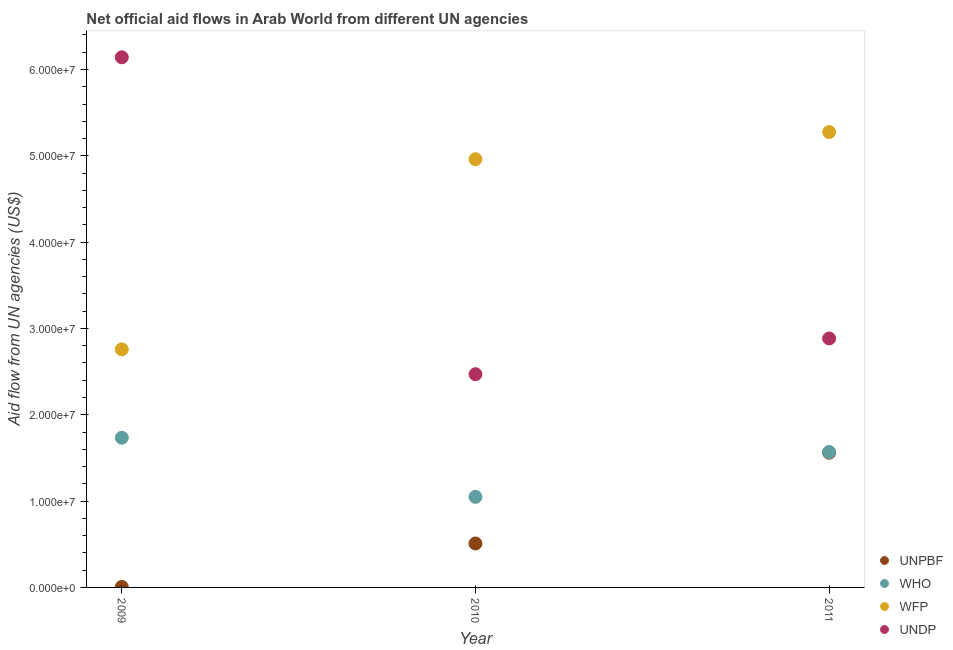How many different coloured dotlines are there?
Your answer should be very brief. 4. What is the amount of aid given by wfp in 2009?
Ensure brevity in your answer.  2.76e+07. Across all years, what is the maximum amount of aid given by who?
Keep it short and to the point. 1.73e+07. Across all years, what is the minimum amount of aid given by who?
Provide a succinct answer. 1.05e+07. In which year was the amount of aid given by who minimum?
Your answer should be compact. 2010. What is the total amount of aid given by undp in the graph?
Your answer should be very brief. 1.15e+08. What is the difference between the amount of aid given by undp in 2009 and that in 2010?
Make the answer very short. 3.67e+07. What is the difference between the amount of aid given by unpbf in 2010 and the amount of aid given by undp in 2009?
Make the answer very short. -5.63e+07. What is the average amount of aid given by unpbf per year?
Provide a short and direct response. 6.92e+06. In the year 2010, what is the difference between the amount of aid given by undp and amount of aid given by who?
Your answer should be compact. 1.42e+07. In how many years, is the amount of aid given by unpbf greater than 8000000 US$?
Keep it short and to the point. 1. What is the ratio of the amount of aid given by wfp in 2009 to that in 2010?
Provide a short and direct response. 0.56. What is the difference between the highest and the second highest amount of aid given by wfp?
Keep it short and to the point. 3.14e+06. What is the difference between the highest and the lowest amount of aid given by undp?
Your response must be concise. 3.67e+07. Is it the case that in every year, the sum of the amount of aid given by unpbf and amount of aid given by who is greater than the amount of aid given by wfp?
Give a very brief answer. No. Is the amount of aid given by undp strictly less than the amount of aid given by wfp over the years?
Your answer should be very brief. No. What is the difference between two consecutive major ticks on the Y-axis?
Give a very brief answer. 1.00e+07. Are the values on the major ticks of Y-axis written in scientific E-notation?
Keep it short and to the point. Yes. What is the title of the graph?
Offer a very short reply. Net official aid flows in Arab World from different UN agencies. Does "Greece" appear as one of the legend labels in the graph?
Ensure brevity in your answer.  No. What is the label or title of the Y-axis?
Give a very brief answer. Aid flow from UN agencies (US$). What is the Aid flow from UN agencies (US$) in UNPBF in 2009?
Give a very brief answer. 6.00e+04. What is the Aid flow from UN agencies (US$) of WHO in 2009?
Your answer should be compact. 1.73e+07. What is the Aid flow from UN agencies (US$) of WFP in 2009?
Ensure brevity in your answer.  2.76e+07. What is the Aid flow from UN agencies (US$) of UNDP in 2009?
Make the answer very short. 6.14e+07. What is the Aid flow from UN agencies (US$) of UNPBF in 2010?
Your response must be concise. 5.09e+06. What is the Aid flow from UN agencies (US$) in WHO in 2010?
Make the answer very short. 1.05e+07. What is the Aid flow from UN agencies (US$) in WFP in 2010?
Ensure brevity in your answer.  4.96e+07. What is the Aid flow from UN agencies (US$) of UNDP in 2010?
Provide a succinct answer. 2.47e+07. What is the Aid flow from UN agencies (US$) in UNPBF in 2011?
Your response must be concise. 1.56e+07. What is the Aid flow from UN agencies (US$) in WHO in 2011?
Offer a very short reply. 1.57e+07. What is the Aid flow from UN agencies (US$) of WFP in 2011?
Keep it short and to the point. 5.28e+07. What is the Aid flow from UN agencies (US$) of UNDP in 2011?
Your answer should be compact. 2.88e+07. Across all years, what is the maximum Aid flow from UN agencies (US$) in UNPBF?
Provide a succinct answer. 1.56e+07. Across all years, what is the maximum Aid flow from UN agencies (US$) in WHO?
Your answer should be very brief. 1.73e+07. Across all years, what is the maximum Aid flow from UN agencies (US$) in WFP?
Ensure brevity in your answer.  5.28e+07. Across all years, what is the maximum Aid flow from UN agencies (US$) in UNDP?
Keep it short and to the point. 6.14e+07. Across all years, what is the minimum Aid flow from UN agencies (US$) of UNPBF?
Keep it short and to the point. 6.00e+04. Across all years, what is the minimum Aid flow from UN agencies (US$) of WHO?
Offer a very short reply. 1.05e+07. Across all years, what is the minimum Aid flow from UN agencies (US$) in WFP?
Provide a succinct answer. 2.76e+07. Across all years, what is the minimum Aid flow from UN agencies (US$) in UNDP?
Your answer should be compact. 2.47e+07. What is the total Aid flow from UN agencies (US$) of UNPBF in the graph?
Offer a very short reply. 2.08e+07. What is the total Aid flow from UN agencies (US$) in WHO in the graph?
Offer a terse response. 4.35e+07. What is the total Aid flow from UN agencies (US$) of WFP in the graph?
Offer a terse response. 1.30e+08. What is the total Aid flow from UN agencies (US$) of UNDP in the graph?
Give a very brief answer. 1.15e+08. What is the difference between the Aid flow from UN agencies (US$) of UNPBF in 2009 and that in 2010?
Provide a succinct answer. -5.03e+06. What is the difference between the Aid flow from UN agencies (US$) in WHO in 2009 and that in 2010?
Your response must be concise. 6.85e+06. What is the difference between the Aid flow from UN agencies (US$) in WFP in 2009 and that in 2010?
Give a very brief answer. -2.20e+07. What is the difference between the Aid flow from UN agencies (US$) in UNDP in 2009 and that in 2010?
Offer a terse response. 3.67e+07. What is the difference between the Aid flow from UN agencies (US$) of UNPBF in 2009 and that in 2011?
Keep it short and to the point. -1.56e+07. What is the difference between the Aid flow from UN agencies (US$) of WHO in 2009 and that in 2011?
Your answer should be very brief. 1.65e+06. What is the difference between the Aid flow from UN agencies (US$) in WFP in 2009 and that in 2011?
Your answer should be very brief. -2.52e+07. What is the difference between the Aid flow from UN agencies (US$) in UNDP in 2009 and that in 2011?
Your answer should be very brief. 3.26e+07. What is the difference between the Aid flow from UN agencies (US$) of UNPBF in 2010 and that in 2011?
Provide a short and direct response. -1.05e+07. What is the difference between the Aid flow from UN agencies (US$) in WHO in 2010 and that in 2011?
Provide a short and direct response. -5.20e+06. What is the difference between the Aid flow from UN agencies (US$) in WFP in 2010 and that in 2011?
Keep it short and to the point. -3.14e+06. What is the difference between the Aid flow from UN agencies (US$) of UNDP in 2010 and that in 2011?
Your answer should be very brief. -4.14e+06. What is the difference between the Aid flow from UN agencies (US$) in UNPBF in 2009 and the Aid flow from UN agencies (US$) in WHO in 2010?
Your answer should be very brief. -1.04e+07. What is the difference between the Aid flow from UN agencies (US$) in UNPBF in 2009 and the Aid flow from UN agencies (US$) in WFP in 2010?
Offer a very short reply. -4.96e+07. What is the difference between the Aid flow from UN agencies (US$) of UNPBF in 2009 and the Aid flow from UN agencies (US$) of UNDP in 2010?
Your response must be concise. -2.46e+07. What is the difference between the Aid flow from UN agencies (US$) in WHO in 2009 and the Aid flow from UN agencies (US$) in WFP in 2010?
Provide a short and direct response. -3.23e+07. What is the difference between the Aid flow from UN agencies (US$) of WHO in 2009 and the Aid flow from UN agencies (US$) of UNDP in 2010?
Ensure brevity in your answer.  -7.36e+06. What is the difference between the Aid flow from UN agencies (US$) of WFP in 2009 and the Aid flow from UN agencies (US$) of UNDP in 2010?
Provide a succinct answer. 2.88e+06. What is the difference between the Aid flow from UN agencies (US$) of UNPBF in 2009 and the Aid flow from UN agencies (US$) of WHO in 2011?
Make the answer very short. -1.56e+07. What is the difference between the Aid flow from UN agencies (US$) in UNPBF in 2009 and the Aid flow from UN agencies (US$) in WFP in 2011?
Provide a short and direct response. -5.27e+07. What is the difference between the Aid flow from UN agencies (US$) in UNPBF in 2009 and the Aid flow from UN agencies (US$) in UNDP in 2011?
Provide a succinct answer. -2.88e+07. What is the difference between the Aid flow from UN agencies (US$) of WHO in 2009 and the Aid flow from UN agencies (US$) of WFP in 2011?
Give a very brief answer. -3.54e+07. What is the difference between the Aid flow from UN agencies (US$) of WHO in 2009 and the Aid flow from UN agencies (US$) of UNDP in 2011?
Keep it short and to the point. -1.15e+07. What is the difference between the Aid flow from UN agencies (US$) in WFP in 2009 and the Aid flow from UN agencies (US$) in UNDP in 2011?
Ensure brevity in your answer.  -1.26e+06. What is the difference between the Aid flow from UN agencies (US$) of UNPBF in 2010 and the Aid flow from UN agencies (US$) of WHO in 2011?
Your response must be concise. -1.06e+07. What is the difference between the Aid flow from UN agencies (US$) of UNPBF in 2010 and the Aid flow from UN agencies (US$) of WFP in 2011?
Your response must be concise. -4.77e+07. What is the difference between the Aid flow from UN agencies (US$) in UNPBF in 2010 and the Aid flow from UN agencies (US$) in UNDP in 2011?
Ensure brevity in your answer.  -2.38e+07. What is the difference between the Aid flow from UN agencies (US$) in WHO in 2010 and the Aid flow from UN agencies (US$) in WFP in 2011?
Offer a terse response. -4.23e+07. What is the difference between the Aid flow from UN agencies (US$) in WHO in 2010 and the Aid flow from UN agencies (US$) in UNDP in 2011?
Give a very brief answer. -1.84e+07. What is the difference between the Aid flow from UN agencies (US$) in WFP in 2010 and the Aid flow from UN agencies (US$) in UNDP in 2011?
Offer a very short reply. 2.08e+07. What is the average Aid flow from UN agencies (US$) in UNPBF per year?
Offer a very short reply. 6.92e+06. What is the average Aid flow from UN agencies (US$) in WHO per year?
Offer a terse response. 1.45e+07. What is the average Aid flow from UN agencies (US$) in WFP per year?
Offer a very short reply. 4.33e+07. What is the average Aid flow from UN agencies (US$) in UNDP per year?
Provide a succinct answer. 3.83e+07. In the year 2009, what is the difference between the Aid flow from UN agencies (US$) of UNPBF and Aid flow from UN agencies (US$) of WHO?
Ensure brevity in your answer.  -1.73e+07. In the year 2009, what is the difference between the Aid flow from UN agencies (US$) in UNPBF and Aid flow from UN agencies (US$) in WFP?
Your response must be concise. -2.75e+07. In the year 2009, what is the difference between the Aid flow from UN agencies (US$) of UNPBF and Aid flow from UN agencies (US$) of UNDP?
Offer a very short reply. -6.14e+07. In the year 2009, what is the difference between the Aid flow from UN agencies (US$) in WHO and Aid flow from UN agencies (US$) in WFP?
Keep it short and to the point. -1.02e+07. In the year 2009, what is the difference between the Aid flow from UN agencies (US$) of WHO and Aid flow from UN agencies (US$) of UNDP?
Your answer should be compact. -4.41e+07. In the year 2009, what is the difference between the Aid flow from UN agencies (US$) in WFP and Aid flow from UN agencies (US$) in UNDP?
Keep it short and to the point. -3.38e+07. In the year 2010, what is the difference between the Aid flow from UN agencies (US$) of UNPBF and Aid flow from UN agencies (US$) of WHO?
Keep it short and to the point. -5.40e+06. In the year 2010, what is the difference between the Aid flow from UN agencies (US$) of UNPBF and Aid flow from UN agencies (US$) of WFP?
Give a very brief answer. -4.45e+07. In the year 2010, what is the difference between the Aid flow from UN agencies (US$) in UNPBF and Aid flow from UN agencies (US$) in UNDP?
Make the answer very short. -1.96e+07. In the year 2010, what is the difference between the Aid flow from UN agencies (US$) in WHO and Aid flow from UN agencies (US$) in WFP?
Provide a succinct answer. -3.91e+07. In the year 2010, what is the difference between the Aid flow from UN agencies (US$) in WHO and Aid flow from UN agencies (US$) in UNDP?
Provide a short and direct response. -1.42e+07. In the year 2010, what is the difference between the Aid flow from UN agencies (US$) of WFP and Aid flow from UN agencies (US$) of UNDP?
Offer a terse response. 2.49e+07. In the year 2011, what is the difference between the Aid flow from UN agencies (US$) in UNPBF and Aid flow from UN agencies (US$) in WHO?
Provide a short and direct response. -8.00e+04. In the year 2011, what is the difference between the Aid flow from UN agencies (US$) of UNPBF and Aid flow from UN agencies (US$) of WFP?
Provide a short and direct response. -3.71e+07. In the year 2011, what is the difference between the Aid flow from UN agencies (US$) in UNPBF and Aid flow from UN agencies (US$) in UNDP?
Your answer should be very brief. -1.32e+07. In the year 2011, what is the difference between the Aid flow from UN agencies (US$) of WHO and Aid flow from UN agencies (US$) of WFP?
Provide a succinct answer. -3.71e+07. In the year 2011, what is the difference between the Aid flow from UN agencies (US$) in WHO and Aid flow from UN agencies (US$) in UNDP?
Keep it short and to the point. -1.32e+07. In the year 2011, what is the difference between the Aid flow from UN agencies (US$) in WFP and Aid flow from UN agencies (US$) in UNDP?
Provide a succinct answer. 2.39e+07. What is the ratio of the Aid flow from UN agencies (US$) of UNPBF in 2009 to that in 2010?
Provide a short and direct response. 0.01. What is the ratio of the Aid flow from UN agencies (US$) in WHO in 2009 to that in 2010?
Your answer should be compact. 1.65. What is the ratio of the Aid flow from UN agencies (US$) of WFP in 2009 to that in 2010?
Provide a short and direct response. 0.56. What is the ratio of the Aid flow from UN agencies (US$) in UNDP in 2009 to that in 2010?
Ensure brevity in your answer.  2.49. What is the ratio of the Aid flow from UN agencies (US$) in UNPBF in 2009 to that in 2011?
Offer a very short reply. 0. What is the ratio of the Aid flow from UN agencies (US$) in WHO in 2009 to that in 2011?
Your answer should be very brief. 1.11. What is the ratio of the Aid flow from UN agencies (US$) of WFP in 2009 to that in 2011?
Make the answer very short. 0.52. What is the ratio of the Aid flow from UN agencies (US$) in UNDP in 2009 to that in 2011?
Your answer should be very brief. 2.13. What is the ratio of the Aid flow from UN agencies (US$) of UNPBF in 2010 to that in 2011?
Provide a succinct answer. 0.33. What is the ratio of the Aid flow from UN agencies (US$) of WHO in 2010 to that in 2011?
Ensure brevity in your answer.  0.67. What is the ratio of the Aid flow from UN agencies (US$) of WFP in 2010 to that in 2011?
Offer a very short reply. 0.94. What is the ratio of the Aid flow from UN agencies (US$) in UNDP in 2010 to that in 2011?
Your answer should be very brief. 0.86. What is the difference between the highest and the second highest Aid flow from UN agencies (US$) of UNPBF?
Offer a very short reply. 1.05e+07. What is the difference between the highest and the second highest Aid flow from UN agencies (US$) in WHO?
Provide a short and direct response. 1.65e+06. What is the difference between the highest and the second highest Aid flow from UN agencies (US$) of WFP?
Offer a terse response. 3.14e+06. What is the difference between the highest and the second highest Aid flow from UN agencies (US$) in UNDP?
Your answer should be very brief. 3.26e+07. What is the difference between the highest and the lowest Aid flow from UN agencies (US$) of UNPBF?
Give a very brief answer. 1.56e+07. What is the difference between the highest and the lowest Aid flow from UN agencies (US$) of WHO?
Ensure brevity in your answer.  6.85e+06. What is the difference between the highest and the lowest Aid flow from UN agencies (US$) in WFP?
Offer a very short reply. 2.52e+07. What is the difference between the highest and the lowest Aid flow from UN agencies (US$) in UNDP?
Your answer should be compact. 3.67e+07. 